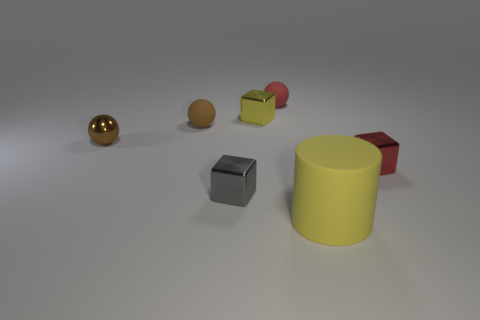Are there the same number of small yellow objects that are behind the cylinder and matte balls?
Offer a terse response. No. There is a tiny matte sphere to the left of the metal cube behind the small red metallic block; how many big rubber things are on the left side of it?
Your response must be concise. 0. Are there any green metal balls that have the same size as the yellow shiny thing?
Provide a succinct answer. No. Is the number of small brown spheres that are to the left of the tiny yellow shiny object less than the number of small red metallic blocks?
Ensure brevity in your answer.  No. There is a object to the left of the tiny rubber sphere in front of the tiny cube that is behind the brown rubber thing; what is its material?
Make the answer very short. Metal. Is the number of brown balls on the right side of the yellow rubber cylinder greater than the number of brown objects that are left of the small brown matte object?
Ensure brevity in your answer.  No. What number of rubber objects are either gray things or purple cubes?
Make the answer very short. 0. There is a tiny object that is the same color as the large thing; what is its shape?
Make the answer very short. Cube. What is the tiny ball that is right of the brown rubber ball made of?
Offer a terse response. Rubber. How many objects are yellow cubes or cubes in front of the red block?
Provide a short and direct response. 2. 